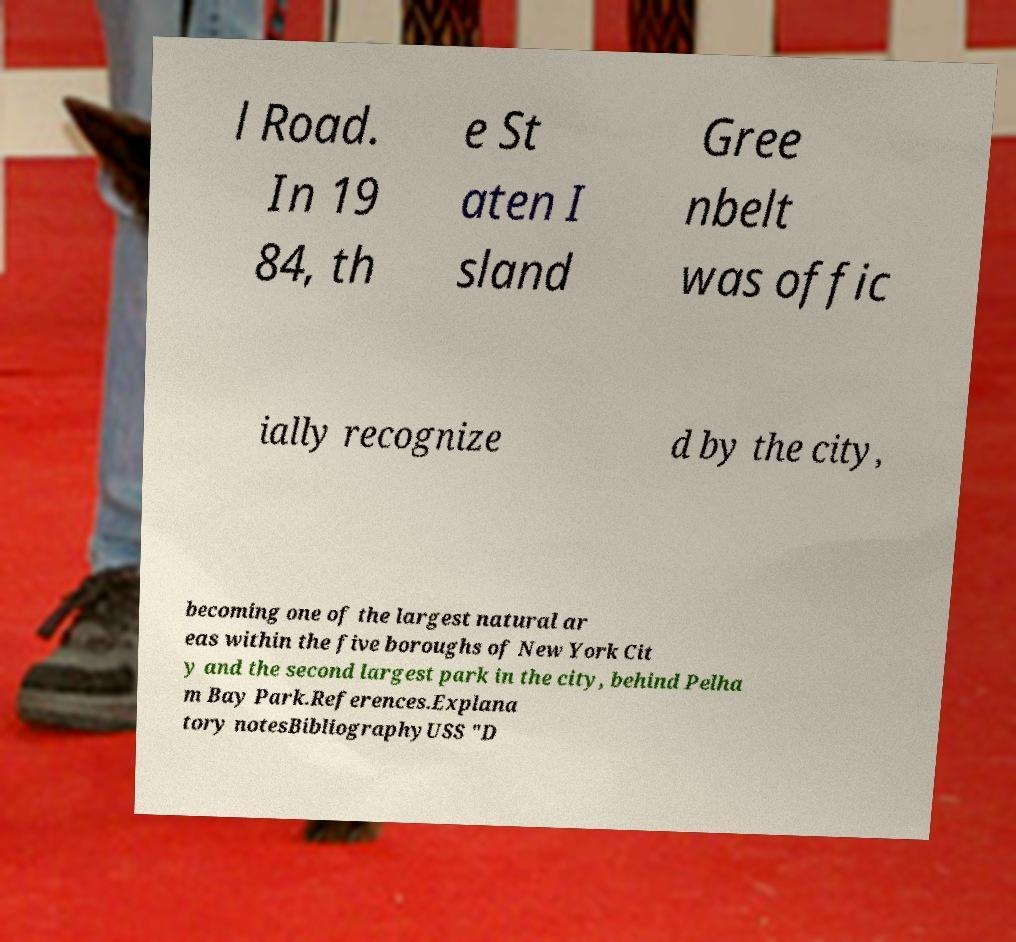Could you extract and type out the text from this image? l Road. In 19 84, th e St aten I sland Gree nbelt was offic ially recognize d by the city, becoming one of the largest natural ar eas within the five boroughs of New York Cit y and the second largest park in the city, behind Pelha m Bay Park.References.Explana tory notesBibliographyUSS "D 